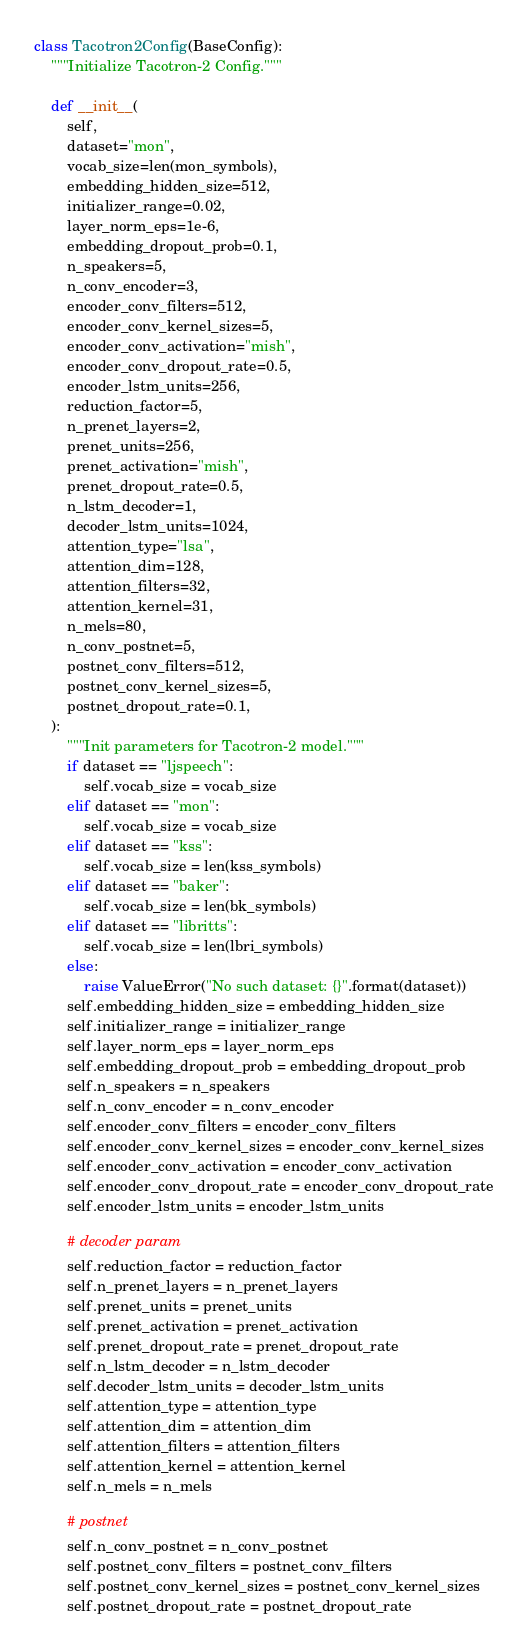<code> <loc_0><loc_0><loc_500><loc_500><_Python_>

class Tacotron2Config(BaseConfig):
    """Initialize Tacotron-2 Config."""

    def __init__(
        self,
        dataset="mon",
        vocab_size=len(mon_symbols),
        embedding_hidden_size=512,
        initializer_range=0.02,
        layer_norm_eps=1e-6,
        embedding_dropout_prob=0.1,
        n_speakers=5,
        n_conv_encoder=3,
        encoder_conv_filters=512,
        encoder_conv_kernel_sizes=5,
        encoder_conv_activation="mish",
        encoder_conv_dropout_rate=0.5,
        encoder_lstm_units=256,
        reduction_factor=5,
        n_prenet_layers=2,
        prenet_units=256,
        prenet_activation="mish",
        prenet_dropout_rate=0.5,
        n_lstm_decoder=1,
        decoder_lstm_units=1024,
        attention_type="lsa",
        attention_dim=128,
        attention_filters=32,
        attention_kernel=31,
        n_mels=80,
        n_conv_postnet=5,
        postnet_conv_filters=512,
        postnet_conv_kernel_sizes=5,
        postnet_dropout_rate=0.1,
    ):
        """Init parameters for Tacotron-2 model."""
        if dataset == "ljspeech":
            self.vocab_size = vocab_size
        elif dataset == "mon":
            self.vocab_size = vocab_size
        elif dataset == "kss":
            self.vocab_size = len(kss_symbols)
        elif dataset == "baker":
            self.vocab_size = len(bk_symbols)
        elif dataset == "libritts":
            self.vocab_size = len(lbri_symbols)
        else:
            raise ValueError("No such dataset: {}".format(dataset))
        self.embedding_hidden_size = embedding_hidden_size
        self.initializer_range = initializer_range
        self.layer_norm_eps = layer_norm_eps
        self.embedding_dropout_prob = embedding_dropout_prob
        self.n_speakers = n_speakers
        self.n_conv_encoder = n_conv_encoder
        self.encoder_conv_filters = encoder_conv_filters
        self.encoder_conv_kernel_sizes = encoder_conv_kernel_sizes
        self.encoder_conv_activation = encoder_conv_activation
        self.encoder_conv_dropout_rate = encoder_conv_dropout_rate
        self.encoder_lstm_units = encoder_lstm_units

        # decoder param
        self.reduction_factor = reduction_factor
        self.n_prenet_layers = n_prenet_layers
        self.prenet_units = prenet_units
        self.prenet_activation = prenet_activation
        self.prenet_dropout_rate = prenet_dropout_rate
        self.n_lstm_decoder = n_lstm_decoder
        self.decoder_lstm_units = decoder_lstm_units
        self.attention_type = attention_type
        self.attention_dim = attention_dim
        self.attention_filters = attention_filters
        self.attention_kernel = attention_kernel
        self.n_mels = n_mels

        # postnet
        self.n_conv_postnet = n_conv_postnet
        self.postnet_conv_filters = postnet_conv_filters
        self.postnet_conv_kernel_sizes = postnet_conv_kernel_sizes
        self.postnet_dropout_rate = postnet_dropout_rate
</code> 